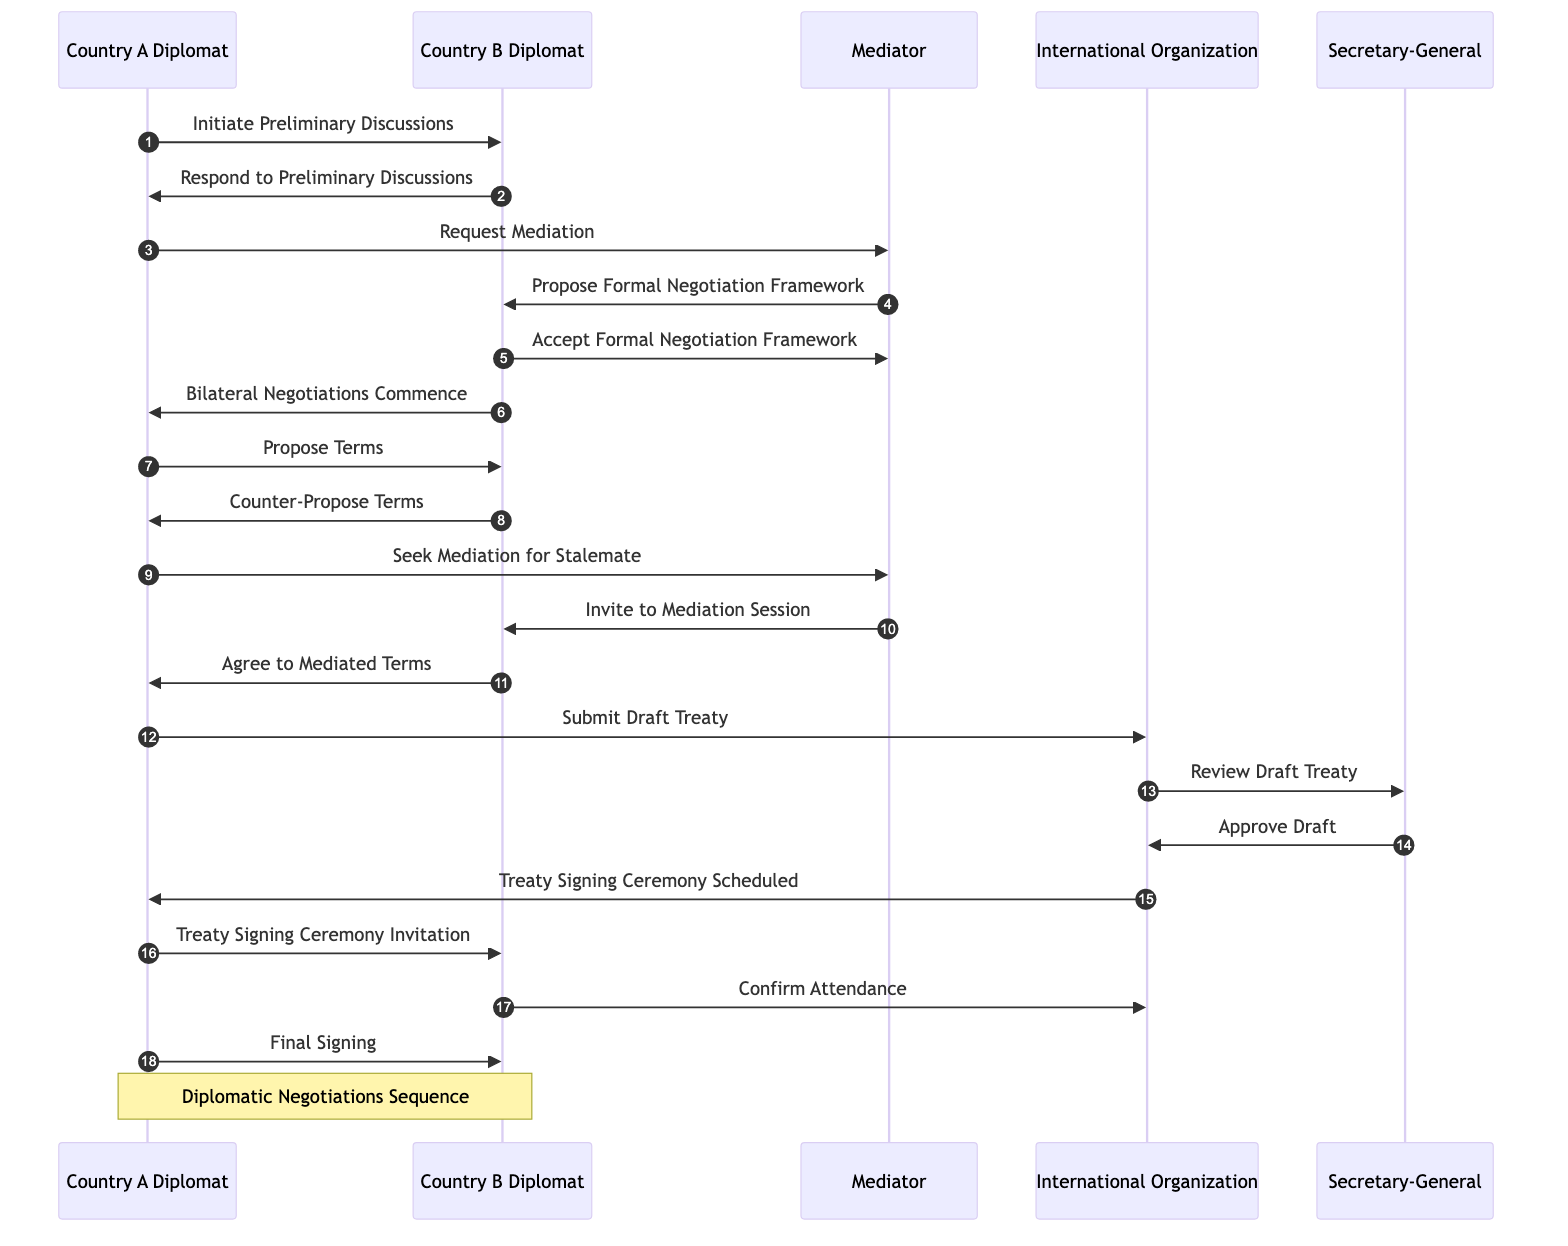What is the first message exchanged in the diagram? The first message exchanged is "Initiate Preliminary Discussions" from Country A Diplomat to Country B Diplomat. This is the first step in the sequence of diplomatic negotiations.
Answer: Initiate Preliminary Discussions How many total participants are involved in the negotiation sequence? There are six participants listed: Country A Diplomat, Country B Diplomat, Mediator, International Organization, and Secretary-General. To count, we simply tally the unique entities mentioned.
Answer: 6 Who proposes the formal negotiation framework? The Mediator is responsible for proposing the formal negotiation framework after being requested for mediation. This is highlighted in the flow of messages in the diagram.
Answer: Mediator At what point does the Bilateral Negotiations Commence? Bilateral Negotiations commence after the Country B Diplomat responds to accept the formal negotiation framework. This indicates a transition from an agreement to actual negotiations.
Answer: Bilateral Negotiations Commence Which entity reviews the draft treaty? The International Organization sends the draft treaty to the Secretary-General for review. This step ensures that the treaty is examined before approval is given.
Answer: Secretary-General What happens after the Treaty Signing Ceremony is scheduled? After the Treaty Signing Ceremony is scheduled, Country A Diplomat sends a Treaty Signing Ceremony Invitation to Country B Diplomat as the follow-up step in the sequence.
Answer: Treaty Signing Ceremony Invitation What is the last message exchanged in the diagram? The last message exchanged in the sequence is "Final Signing" from Country A Diplomat to Country B Diplomat. This represents the culmination of the negotiation process.
Answer: Final Signing What action does Country A Diplomat take after reaching an agreement on terms? After reaching an agreement, Country A Diplomat proceeds to submit the Draft Treaty to the International Organization for the next step in the process.
Answer: Submit Draft Treaty How many messages are exchanged from the start of preliminary discussions to final signing? A total of fifteen messages are exchanged throughout the sequence, depicting the various stages from discussions to the treaty signing. We count each message flow in the diagram.
Answer: 15 